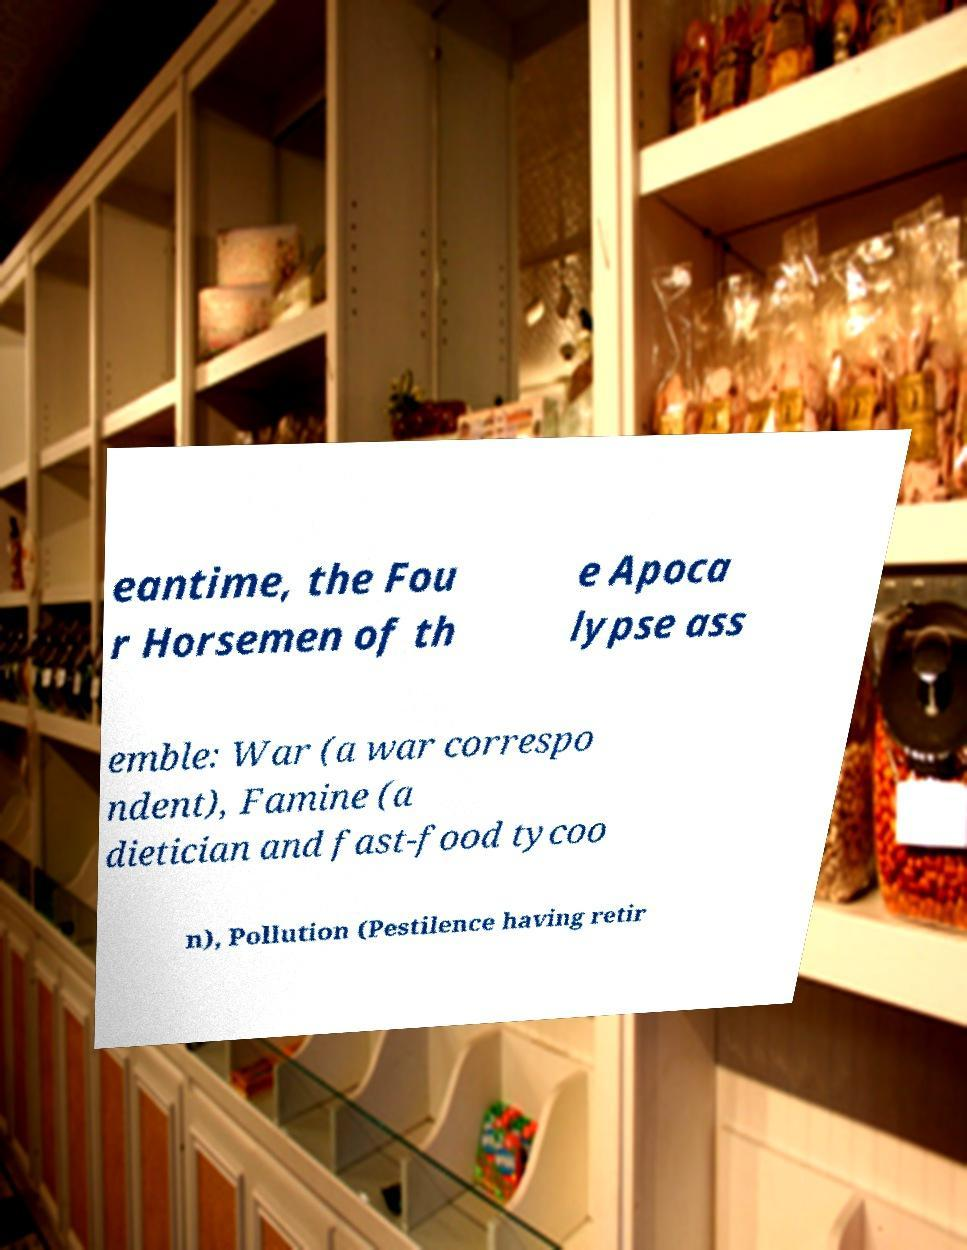There's text embedded in this image that I need extracted. Can you transcribe it verbatim? eantime, the Fou r Horsemen of th e Apoca lypse ass emble: War (a war correspo ndent), Famine (a dietician and fast-food tycoo n), Pollution (Pestilence having retir 